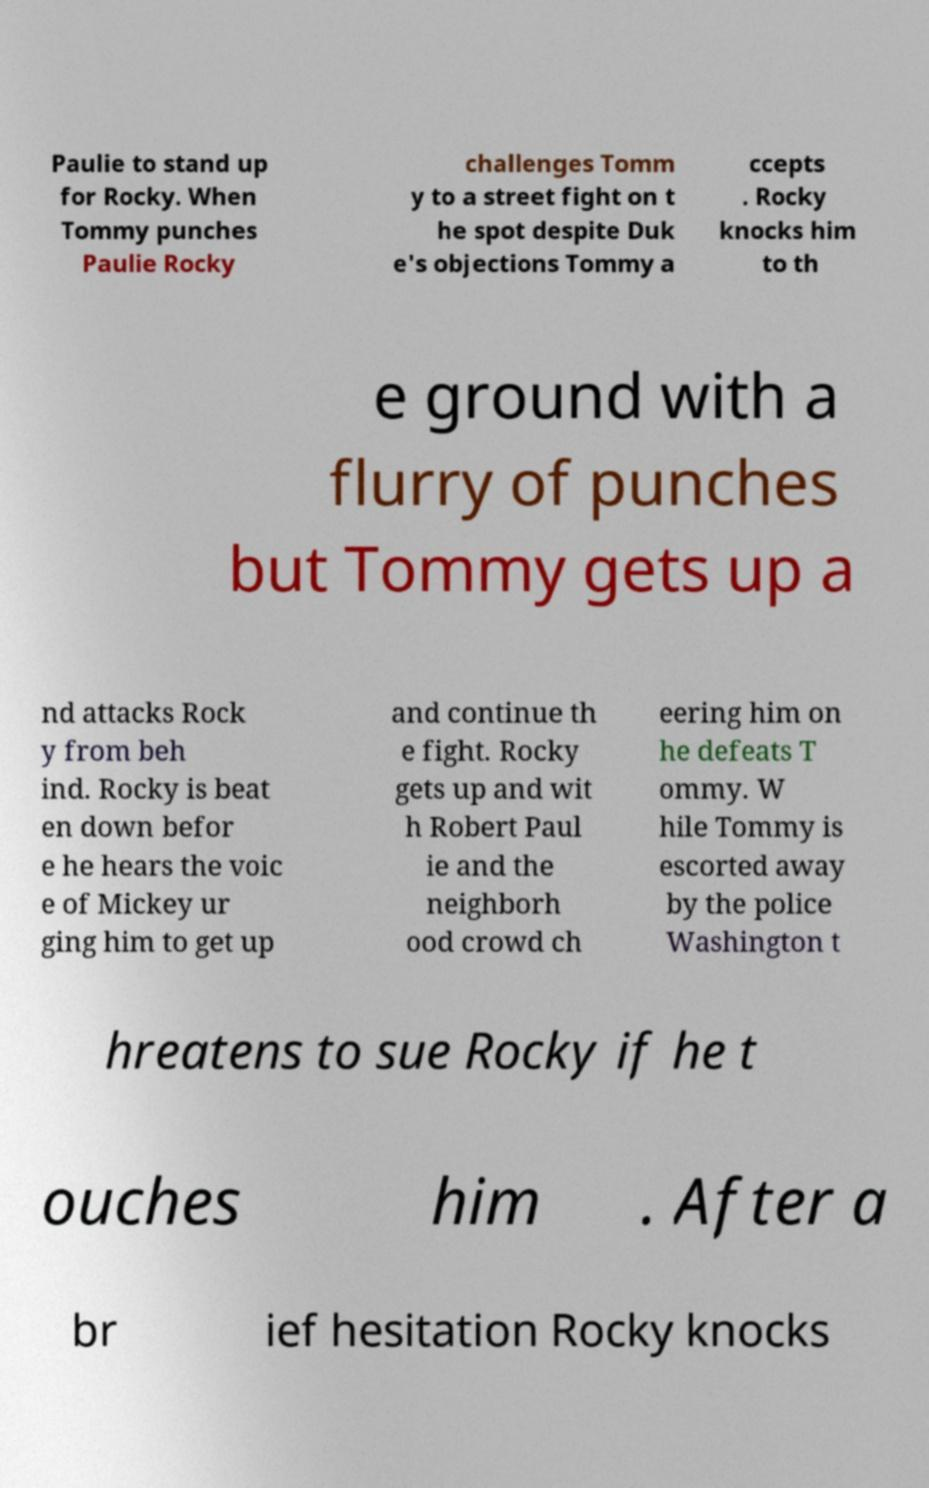Can you accurately transcribe the text from the provided image for me? Paulie to stand up for Rocky. When Tommy punches Paulie Rocky challenges Tomm y to a street fight on t he spot despite Duk e's objections Tommy a ccepts . Rocky knocks him to th e ground with a flurry of punches but Tommy gets up a nd attacks Rock y from beh ind. Rocky is beat en down befor e he hears the voic e of Mickey ur ging him to get up and continue th e fight. Rocky gets up and wit h Robert Paul ie and the neighborh ood crowd ch eering him on he defeats T ommy. W hile Tommy is escorted away by the police Washington t hreatens to sue Rocky if he t ouches him . After a br ief hesitation Rocky knocks 